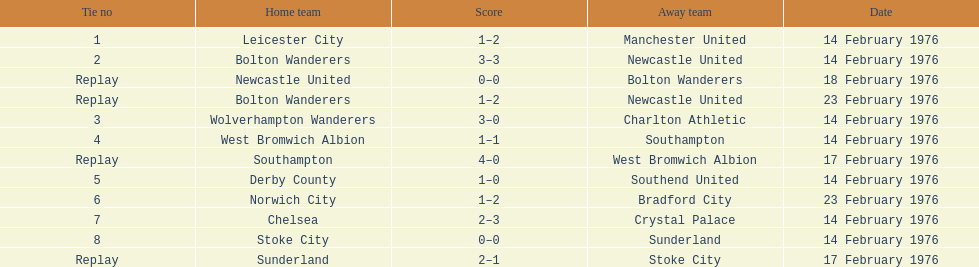How many teams played on february 14th, 1976? 7. I'm looking to parse the entire table for insights. Could you assist me with that? {'header': ['Tie no', 'Home team', 'Score', 'Away team', 'Date'], 'rows': [['1', 'Leicester City', '1–2', 'Manchester United', '14 February 1976'], ['2', 'Bolton Wanderers', '3–3', 'Newcastle United', '14 February 1976'], ['Replay', 'Newcastle United', '0–0', 'Bolton Wanderers', '18 February 1976'], ['Replay', 'Bolton Wanderers', '1–2', 'Newcastle United', '23 February 1976'], ['3', 'Wolverhampton Wanderers', '3–0', 'Charlton Athletic', '14 February 1976'], ['4', 'West Bromwich Albion', '1–1', 'Southampton', '14 February 1976'], ['Replay', 'Southampton', '4–0', 'West Bromwich Albion', '17 February 1976'], ['5', 'Derby County', '1–0', 'Southend United', '14 February 1976'], ['6', 'Norwich City', '1–2', 'Bradford City', '23 February 1976'], ['7', 'Chelsea', '2–3', 'Crystal Palace', '14 February 1976'], ['8', 'Stoke City', '0–0', 'Sunderland', '14 February 1976'], ['Replay', 'Sunderland', '2–1', 'Stoke City', '17 February 1976']]} 